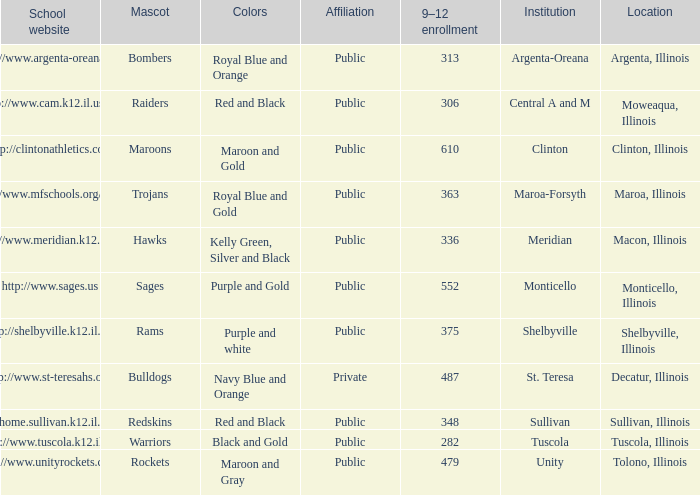What is the designation of the city or municipality that houses the school operating the http://www.mfschools.org/high/ website? Maroa-Forsyth. 